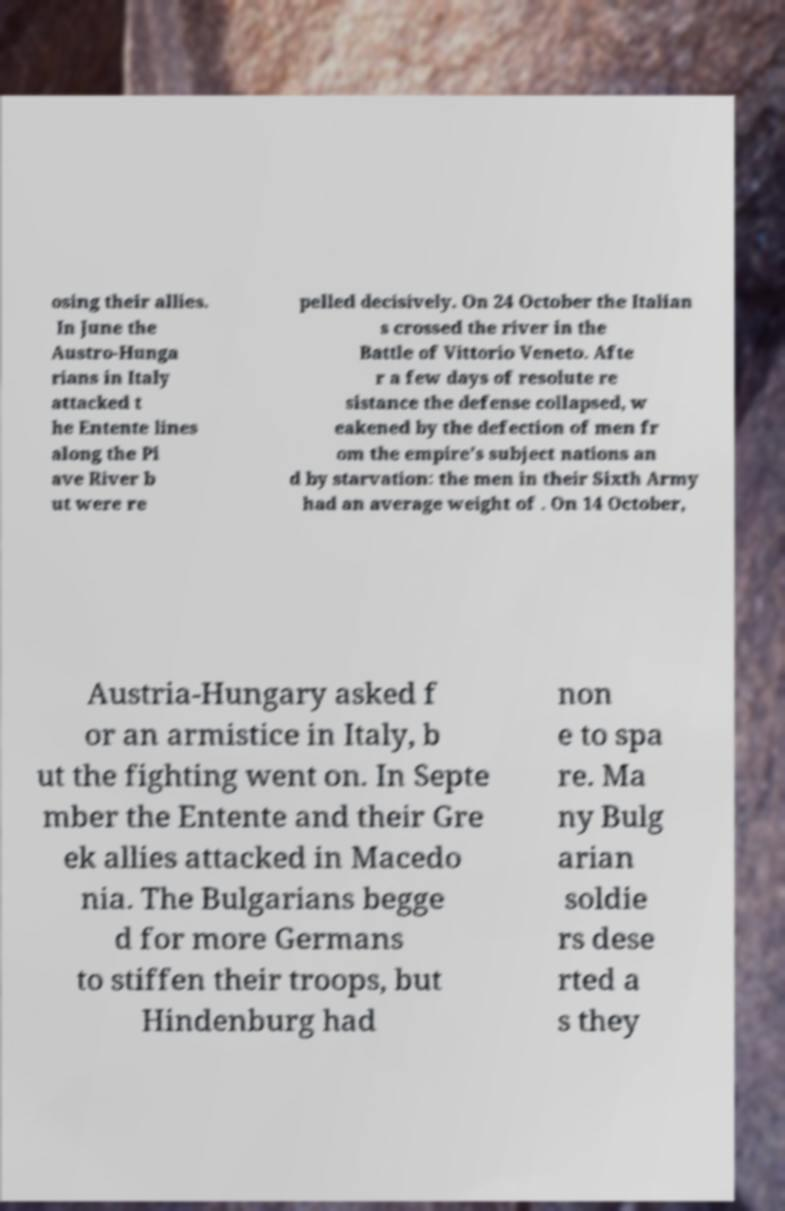What messages or text are displayed in this image? I need them in a readable, typed format. osing their allies. In June the Austro-Hunga rians in Italy attacked t he Entente lines along the Pi ave River b ut were re pelled decisively. On 24 October the Italian s crossed the river in the Battle of Vittorio Veneto. Afte r a few days of resolute re sistance the defense collapsed, w eakened by the defection of men fr om the empire's subject nations an d by starvation: the men in their Sixth Army had an average weight of . On 14 October, Austria-Hungary asked f or an armistice in Italy, b ut the fighting went on. In Septe mber the Entente and their Gre ek allies attacked in Macedo nia. The Bulgarians begge d for more Germans to stiffen their troops, but Hindenburg had non e to spa re. Ma ny Bulg arian soldie rs dese rted a s they 